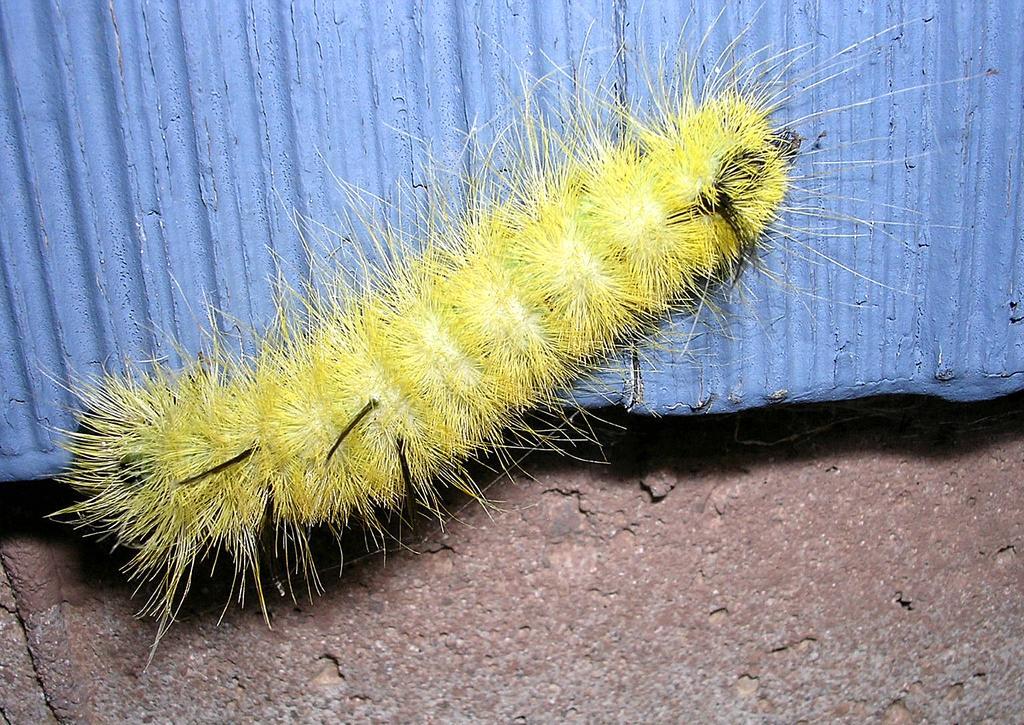What type of insect is in the image? There is a yellow color insect in the image. Where is the insect located? The insect is on the wall. What part of the room can be seen in the image? The floor is visible in the image. What type of ship can be seen sailing in the image? There is no ship present in the image; it features a yellow color insect on the wall. What type of bottle is visible on the wall in the image? There is no bottle present on the wall in the image; it features a yellow color insect. 